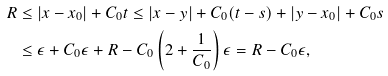<formula> <loc_0><loc_0><loc_500><loc_500>R & \leq | x - x _ { 0 } | + C _ { 0 } t \leq | x - y | + C _ { 0 } ( t - s ) + | y - x _ { 0 } | + C _ { 0 } s \\ & \leq \epsilon + C _ { 0 } \epsilon + R - C _ { 0 } \left ( 2 + \frac { 1 } { C _ { 0 } } \right ) \epsilon = R - C _ { 0 } \epsilon ,</formula> 